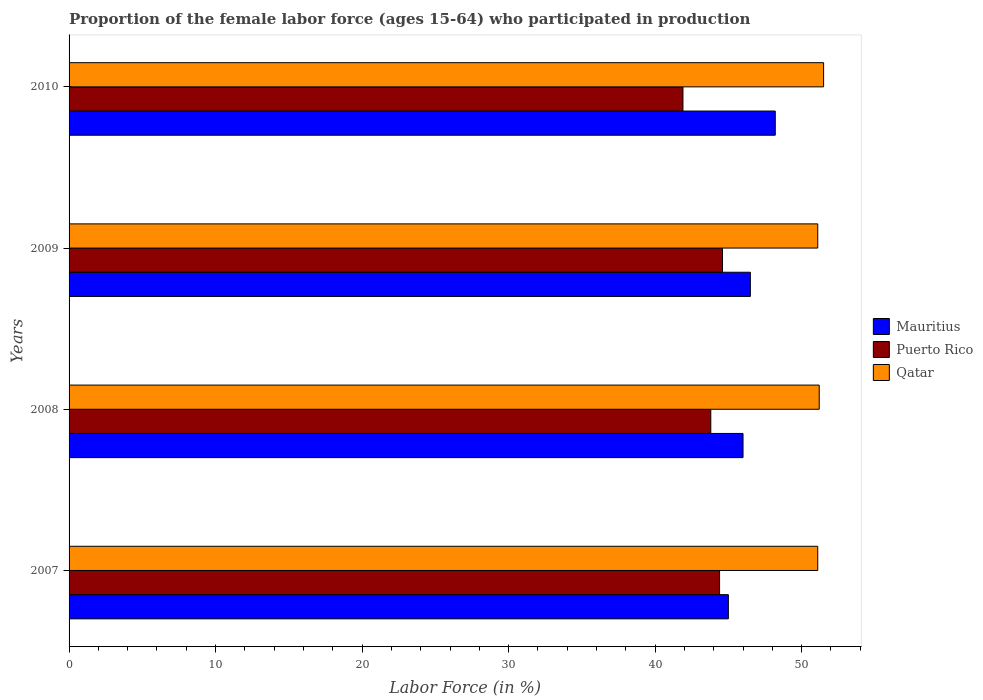Are the number of bars per tick equal to the number of legend labels?
Offer a very short reply. Yes. Are the number of bars on each tick of the Y-axis equal?
Your answer should be very brief. Yes. How many bars are there on the 4th tick from the top?
Make the answer very short. 3. How many bars are there on the 1st tick from the bottom?
Keep it short and to the point. 3. What is the label of the 2nd group of bars from the top?
Provide a short and direct response. 2009. In how many cases, is the number of bars for a given year not equal to the number of legend labels?
Provide a short and direct response. 0. What is the proportion of the female labor force who participated in production in Mauritius in 2009?
Your answer should be very brief. 46.5. Across all years, what is the maximum proportion of the female labor force who participated in production in Qatar?
Ensure brevity in your answer.  51.5. Across all years, what is the minimum proportion of the female labor force who participated in production in Mauritius?
Provide a succinct answer. 45. In which year was the proportion of the female labor force who participated in production in Mauritius minimum?
Ensure brevity in your answer.  2007. What is the total proportion of the female labor force who participated in production in Puerto Rico in the graph?
Offer a very short reply. 174.7. What is the difference between the proportion of the female labor force who participated in production in Qatar in 2010 and the proportion of the female labor force who participated in production in Puerto Rico in 2008?
Make the answer very short. 7.7. What is the average proportion of the female labor force who participated in production in Qatar per year?
Your response must be concise. 51.22. In the year 2007, what is the difference between the proportion of the female labor force who participated in production in Mauritius and proportion of the female labor force who participated in production in Puerto Rico?
Your answer should be compact. 0.6. In how many years, is the proportion of the female labor force who participated in production in Qatar greater than 2 %?
Your answer should be very brief. 4. What is the ratio of the proportion of the female labor force who participated in production in Mauritius in 2008 to that in 2010?
Keep it short and to the point. 0.95. Is the difference between the proportion of the female labor force who participated in production in Mauritius in 2008 and 2009 greater than the difference between the proportion of the female labor force who participated in production in Puerto Rico in 2008 and 2009?
Give a very brief answer. Yes. What is the difference between the highest and the second highest proportion of the female labor force who participated in production in Qatar?
Give a very brief answer. 0.3. What is the difference between the highest and the lowest proportion of the female labor force who participated in production in Qatar?
Provide a succinct answer. 0.4. Is the sum of the proportion of the female labor force who participated in production in Mauritius in 2007 and 2010 greater than the maximum proportion of the female labor force who participated in production in Qatar across all years?
Provide a short and direct response. Yes. What does the 3rd bar from the top in 2009 represents?
Provide a short and direct response. Mauritius. What does the 2nd bar from the bottom in 2009 represents?
Your answer should be very brief. Puerto Rico. Are all the bars in the graph horizontal?
Provide a short and direct response. Yes. What is the difference between two consecutive major ticks on the X-axis?
Make the answer very short. 10. Does the graph contain any zero values?
Your answer should be compact. No. Does the graph contain grids?
Your answer should be very brief. No. Where does the legend appear in the graph?
Offer a very short reply. Center right. What is the title of the graph?
Make the answer very short. Proportion of the female labor force (ages 15-64) who participated in production. Does "Bhutan" appear as one of the legend labels in the graph?
Make the answer very short. No. What is the label or title of the X-axis?
Provide a short and direct response. Labor Force (in %). What is the Labor Force (in %) in Mauritius in 2007?
Provide a succinct answer. 45. What is the Labor Force (in %) in Puerto Rico in 2007?
Offer a very short reply. 44.4. What is the Labor Force (in %) in Qatar in 2007?
Ensure brevity in your answer.  51.1. What is the Labor Force (in %) of Puerto Rico in 2008?
Give a very brief answer. 43.8. What is the Labor Force (in %) of Qatar in 2008?
Your response must be concise. 51.2. What is the Labor Force (in %) in Mauritius in 2009?
Keep it short and to the point. 46.5. What is the Labor Force (in %) of Puerto Rico in 2009?
Provide a succinct answer. 44.6. What is the Labor Force (in %) in Qatar in 2009?
Ensure brevity in your answer.  51.1. What is the Labor Force (in %) of Mauritius in 2010?
Give a very brief answer. 48.2. What is the Labor Force (in %) in Puerto Rico in 2010?
Provide a short and direct response. 41.9. What is the Labor Force (in %) of Qatar in 2010?
Keep it short and to the point. 51.5. Across all years, what is the maximum Labor Force (in %) of Mauritius?
Ensure brevity in your answer.  48.2. Across all years, what is the maximum Labor Force (in %) of Puerto Rico?
Provide a succinct answer. 44.6. Across all years, what is the maximum Labor Force (in %) of Qatar?
Offer a terse response. 51.5. Across all years, what is the minimum Labor Force (in %) in Mauritius?
Your response must be concise. 45. Across all years, what is the minimum Labor Force (in %) of Puerto Rico?
Your response must be concise. 41.9. Across all years, what is the minimum Labor Force (in %) in Qatar?
Ensure brevity in your answer.  51.1. What is the total Labor Force (in %) in Mauritius in the graph?
Keep it short and to the point. 185.7. What is the total Labor Force (in %) in Puerto Rico in the graph?
Your answer should be very brief. 174.7. What is the total Labor Force (in %) in Qatar in the graph?
Offer a terse response. 204.9. What is the difference between the Labor Force (in %) of Mauritius in 2007 and that in 2008?
Your response must be concise. -1. What is the difference between the Labor Force (in %) in Puerto Rico in 2007 and that in 2008?
Offer a terse response. 0.6. What is the difference between the Labor Force (in %) in Puerto Rico in 2007 and that in 2009?
Keep it short and to the point. -0.2. What is the difference between the Labor Force (in %) in Qatar in 2007 and that in 2009?
Give a very brief answer. 0. What is the difference between the Labor Force (in %) in Mauritius in 2007 and that in 2010?
Your response must be concise. -3.2. What is the difference between the Labor Force (in %) in Mauritius in 2008 and that in 2009?
Your answer should be compact. -0.5. What is the difference between the Labor Force (in %) of Puerto Rico in 2008 and that in 2009?
Provide a short and direct response. -0.8. What is the difference between the Labor Force (in %) of Qatar in 2008 and that in 2009?
Keep it short and to the point. 0.1. What is the difference between the Labor Force (in %) in Mauritius in 2008 and that in 2010?
Make the answer very short. -2.2. What is the difference between the Labor Force (in %) in Mauritius in 2009 and that in 2010?
Offer a terse response. -1.7. What is the difference between the Labor Force (in %) in Puerto Rico in 2009 and that in 2010?
Keep it short and to the point. 2.7. What is the difference between the Labor Force (in %) in Mauritius in 2007 and the Labor Force (in %) in Puerto Rico in 2008?
Provide a short and direct response. 1.2. What is the difference between the Labor Force (in %) of Mauritius in 2007 and the Labor Force (in %) of Qatar in 2008?
Ensure brevity in your answer.  -6.2. What is the difference between the Labor Force (in %) in Mauritius in 2007 and the Labor Force (in %) in Puerto Rico in 2010?
Give a very brief answer. 3.1. What is the difference between the Labor Force (in %) of Puerto Rico in 2007 and the Labor Force (in %) of Qatar in 2010?
Offer a very short reply. -7.1. What is the difference between the Labor Force (in %) in Mauritius in 2008 and the Labor Force (in %) in Puerto Rico in 2009?
Your answer should be very brief. 1.4. What is the difference between the Labor Force (in %) in Mauritius in 2008 and the Labor Force (in %) in Qatar in 2009?
Provide a short and direct response. -5.1. What is the difference between the Labor Force (in %) of Puerto Rico in 2008 and the Labor Force (in %) of Qatar in 2009?
Provide a succinct answer. -7.3. What is the difference between the Labor Force (in %) of Mauritius in 2008 and the Labor Force (in %) of Puerto Rico in 2010?
Make the answer very short. 4.1. What is the difference between the Labor Force (in %) in Mauritius in 2008 and the Labor Force (in %) in Qatar in 2010?
Offer a terse response. -5.5. What is the difference between the Labor Force (in %) of Puerto Rico in 2008 and the Labor Force (in %) of Qatar in 2010?
Your answer should be compact. -7.7. What is the difference between the Labor Force (in %) in Mauritius in 2009 and the Labor Force (in %) in Puerto Rico in 2010?
Provide a succinct answer. 4.6. What is the difference between the Labor Force (in %) in Mauritius in 2009 and the Labor Force (in %) in Qatar in 2010?
Give a very brief answer. -5. What is the difference between the Labor Force (in %) in Puerto Rico in 2009 and the Labor Force (in %) in Qatar in 2010?
Make the answer very short. -6.9. What is the average Labor Force (in %) in Mauritius per year?
Your answer should be very brief. 46.42. What is the average Labor Force (in %) of Puerto Rico per year?
Provide a short and direct response. 43.67. What is the average Labor Force (in %) of Qatar per year?
Offer a terse response. 51.23. In the year 2007, what is the difference between the Labor Force (in %) of Mauritius and Labor Force (in %) of Qatar?
Provide a short and direct response. -6.1. In the year 2008, what is the difference between the Labor Force (in %) of Mauritius and Labor Force (in %) of Qatar?
Ensure brevity in your answer.  -5.2. In the year 2009, what is the difference between the Labor Force (in %) of Mauritius and Labor Force (in %) of Qatar?
Offer a very short reply. -4.6. In the year 2009, what is the difference between the Labor Force (in %) in Puerto Rico and Labor Force (in %) in Qatar?
Your response must be concise. -6.5. In the year 2010, what is the difference between the Labor Force (in %) of Mauritius and Labor Force (in %) of Puerto Rico?
Make the answer very short. 6.3. What is the ratio of the Labor Force (in %) of Mauritius in 2007 to that in 2008?
Provide a succinct answer. 0.98. What is the ratio of the Labor Force (in %) in Puerto Rico in 2007 to that in 2008?
Offer a terse response. 1.01. What is the ratio of the Labor Force (in %) of Qatar in 2007 to that in 2009?
Keep it short and to the point. 1. What is the ratio of the Labor Force (in %) in Mauritius in 2007 to that in 2010?
Offer a very short reply. 0.93. What is the ratio of the Labor Force (in %) of Puerto Rico in 2007 to that in 2010?
Offer a very short reply. 1.06. What is the ratio of the Labor Force (in %) in Puerto Rico in 2008 to that in 2009?
Offer a very short reply. 0.98. What is the ratio of the Labor Force (in %) in Mauritius in 2008 to that in 2010?
Provide a succinct answer. 0.95. What is the ratio of the Labor Force (in %) in Puerto Rico in 2008 to that in 2010?
Make the answer very short. 1.05. What is the ratio of the Labor Force (in %) in Qatar in 2008 to that in 2010?
Your answer should be very brief. 0.99. What is the ratio of the Labor Force (in %) in Mauritius in 2009 to that in 2010?
Keep it short and to the point. 0.96. What is the ratio of the Labor Force (in %) of Puerto Rico in 2009 to that in 2010?
Your response must be concise. 1.06. What is the ratio of the Labor Force (in %) in Qatar in 2009 to that in 2010?
Offer a very short reply. 0.99. What is the difference between the highest and the second highest Labor Force (in %) of Mauritius?
Offer a very short reply. 1.7. What is the difference between the highest and the second highest Labor Force (in %) of Puerto Rico?
Make the answer very short. 0.2. What is the difference between the highest and the second highest Labor Force (in %) of Qatar?
Give a very brief answer. 0.3. What is the difference between the highest and the lowest Labor Force (in %) in Mauritius?
Give a very brief answer. 3.2. What is the difference between the highest and the lowest Labor Force (in %) of Puerto Rico?
Ensure brevity in your answer.  2.7. What is the difference between the highest and the lowest Labor Force (in %) in Qatar?
Your answer should be compact. 0.4. 